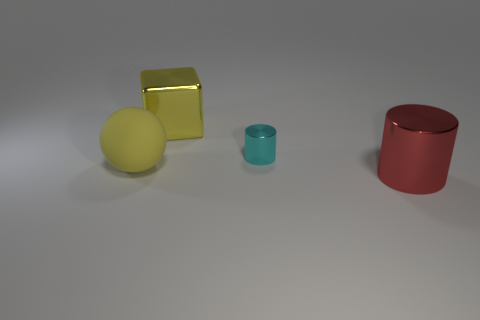Is there any other thing that is the same color as the big shiny cylinder?
Ensure brevity in your answer.  No. There is a object that is both in front of the yellow block and on the left side of the small cylinder; what shape is it?
Your response must be concise. Sphere. Is the number of cubes that are in front of the ball the same as the number of cylinders left of the tiny cylinder?
Your answer should be compact. Yes. How many cubes are large red matte things or big rubber things?
Give a very brief answer. 0. How many other yellow blocks have the same material as the yellow block?
Provide a succinct answer. 0. There is a matte thing that is the same color as the big metallic block; what shape is it?
Your answer should be compact. Sphere. There is a object that is behind the matte thing and right of the block; what is its material?
Ensure brevity in your answer.  Metal. There is a shiny object to the left of the cyan metal thing; what is its shape?
Offer a terse response. Cube. What shape is the small metal object behind the large cylinder that is in front of the tiny cyan cylinder?
Your answer should be very brief. Cylinder. Is there a matte thing of the same shape as the cyan shiny thing?
Provide a succinct answer. No. 